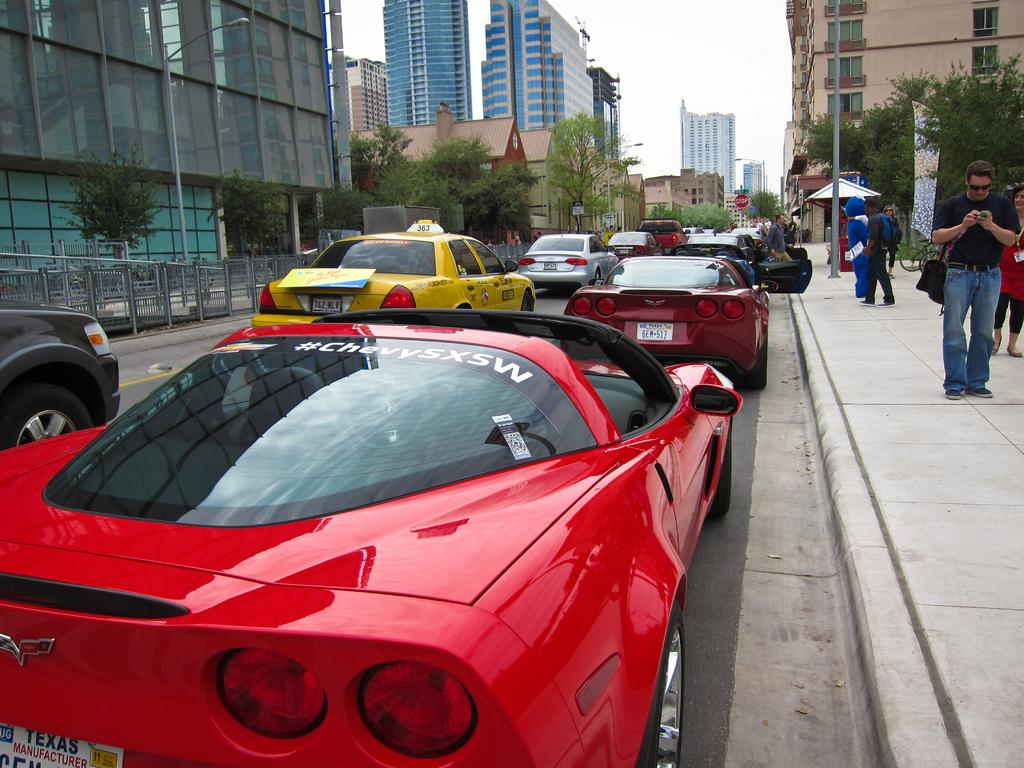<image>
Share a concise interpretation of the image provided. A red Corvette is next to a curb, with a "#ChevySXSW" on the rear windshield. 